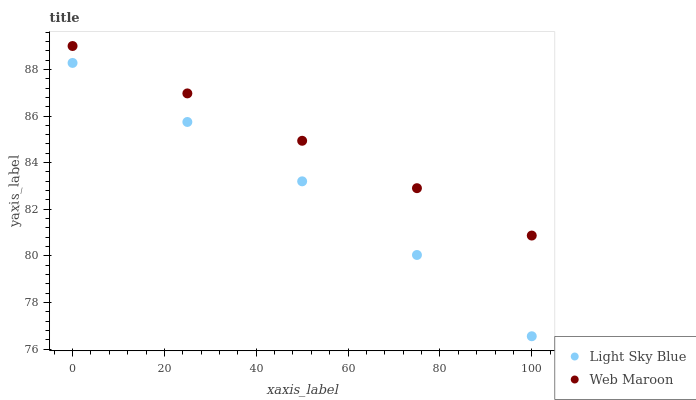Does Light Sky Blue have the minimum area under the curve?
Answer yes or no. Yes. Does Web Maroon have the maximum area under the curve?
Answer yes or no. Yes. Does Web Maroon have the minimum area under the curve?
Answer yes or no. No. Is Web Maroon the smoothest?
Answer yes or no. Yes. Is Light Sky Blue the roughest?
Answer yes or no. Yes. Is Web Maroon the roughest?
Answer yes or no. No. Does Light Sky Blue have the lowest value?
Answer yes or no. Yes. Does Web Maroon have the lowest value?
Answer yes or no. No. Does Web Maroon have the highest value?
Answer yes or no. Yes. Is Light Sky Blue less than Web Maroon?
Answer yes or no. Yes. Is Web Maroon greater than Light Sky Blue?
Answer yes or no. Yes. Does Light Sky Blue intersect Web Maroon?
Answer yes or no. No. 